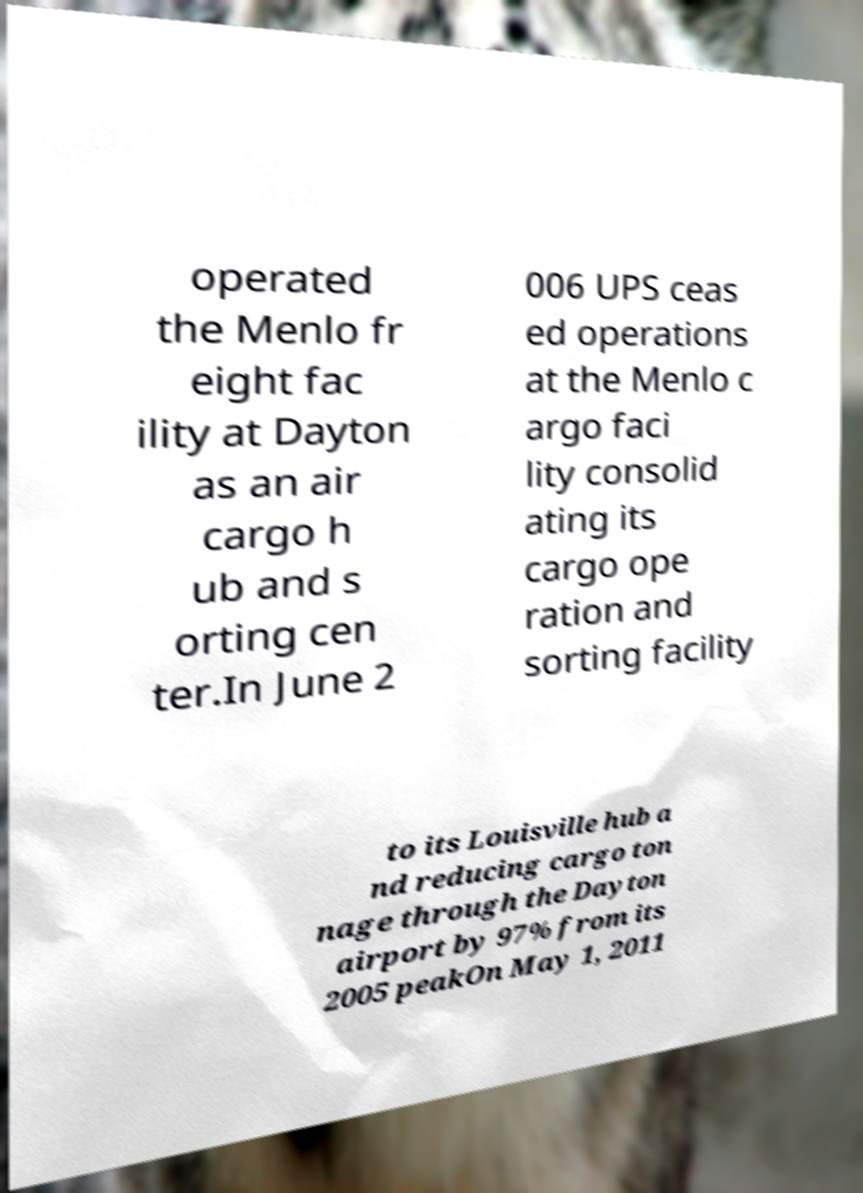Could you extract and type out the text from this image? operated the Menlo fr eight fac ility at Dayton as an air cargo h ub and s orting cen ter.In June 2 006 UPS ceas ed operations at the Menlo c argo faci lity consolid ating its cargo ope ration and sorting facility to its Louisville hub a nd reducing cargo ton nage through the Dayton airport by 97% from its 2005 peakOn May 1, 2011 